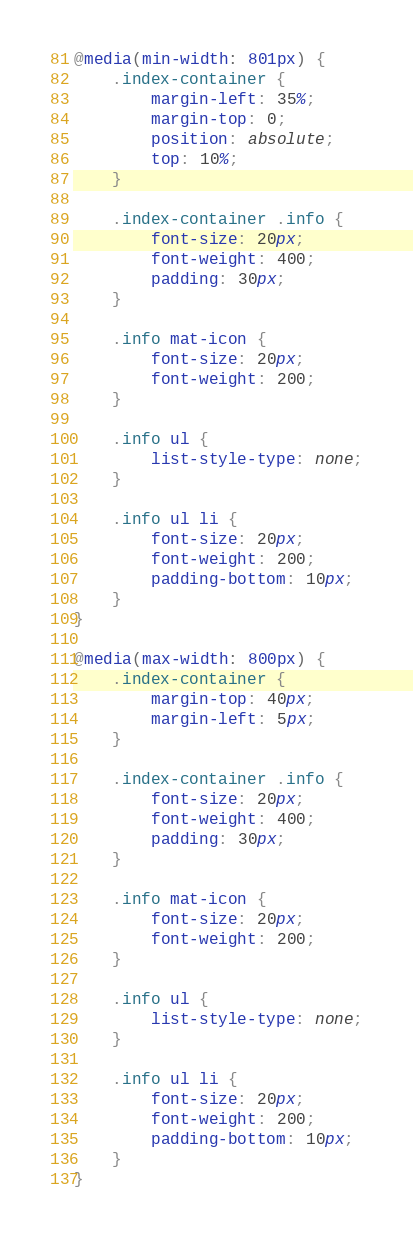Convert code to text. <code><loc_0><loc_0><loc_500><loc_500><_CSS_>@media(min-width: 801px) {
    .index-container {
        margin-left: 35%;
        margin-top: 0;
        position: absolute;
        top: 10%;
    }

    .index-container .info {
        font-size: 20px;
        font-weight: 400;
        padding: 30px;
    }

    .info mat-icon {
        font-size: 20px;
        font-weight: 200;
    }

    .info ul {
        list-style-type: none;
    }

    .info ul li {
        font-size: 20px;
        font-weight: 200;
        padding-bottom: 10px;
    }
}

@media(max-width: 800px) {
    .index-container {
        margin-top: 40px;
        margin-left: 5px;
    }

    .index-container .info {
        font-size: 20px;
        font-weight: 400;
        padding: 30px;
    }

    .info mat-icon {
        font-size: 20px;
        font-weight: 200;
    }

    .info ul {
        list-style-type: none;
    }

    .info ul li {
        font-size: 20px;
        font-weight: 200;
        padding-bottom: 10px;
    }
}</code> 